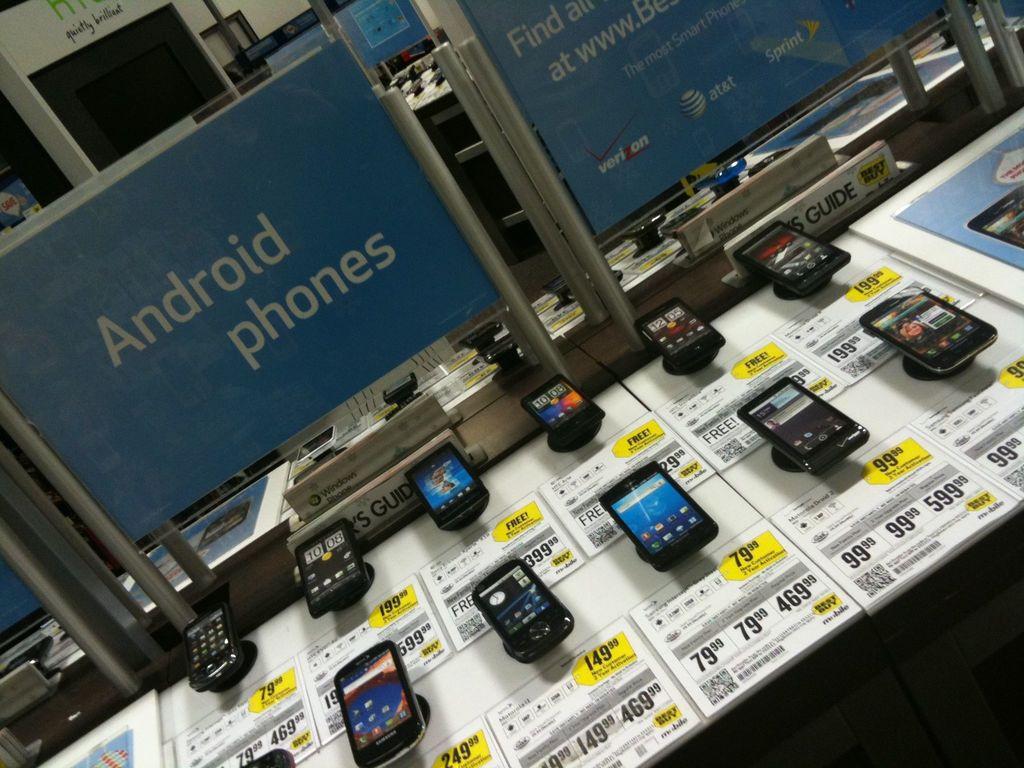What kind of phones are these?
Your answer should be very brief. Android. What kind of phones are these?
Keep it short and to the point. Android. 